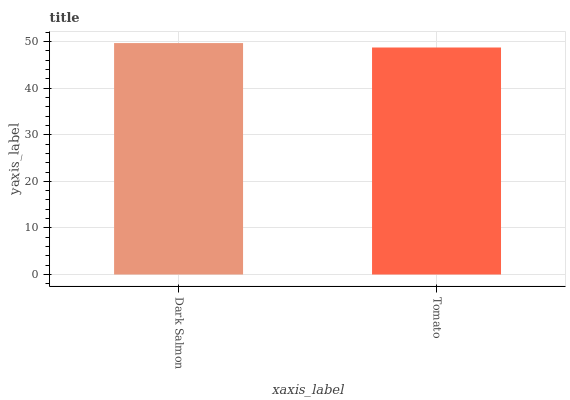Is Tomato the minimum?
Answer yes or no. Yes. Is Dark Salmon the maximum?
Answer yes or no. Yes. Is Tomato the maximum?
Answer yes or no. No. Is Dark Salmon greater than Tomato?
Answer yes or no. Yes. Is Tomato less than Dark Salmon?
Answer yes or no. Yes. Is Tomato greater than Dark Salmon?
Answer yes or no. No. Is Dark Salmon less than Tomato?
Answer yes or no. No. Is Dark Salmon the high median?
Answer yes or no. Yes. Is Tomato the low median?
Answer yes or no. Yes. Is Tomato the high median?
Answer yes or no. No. Is Dark Salmon the low median?
Answer yes or no. No. 